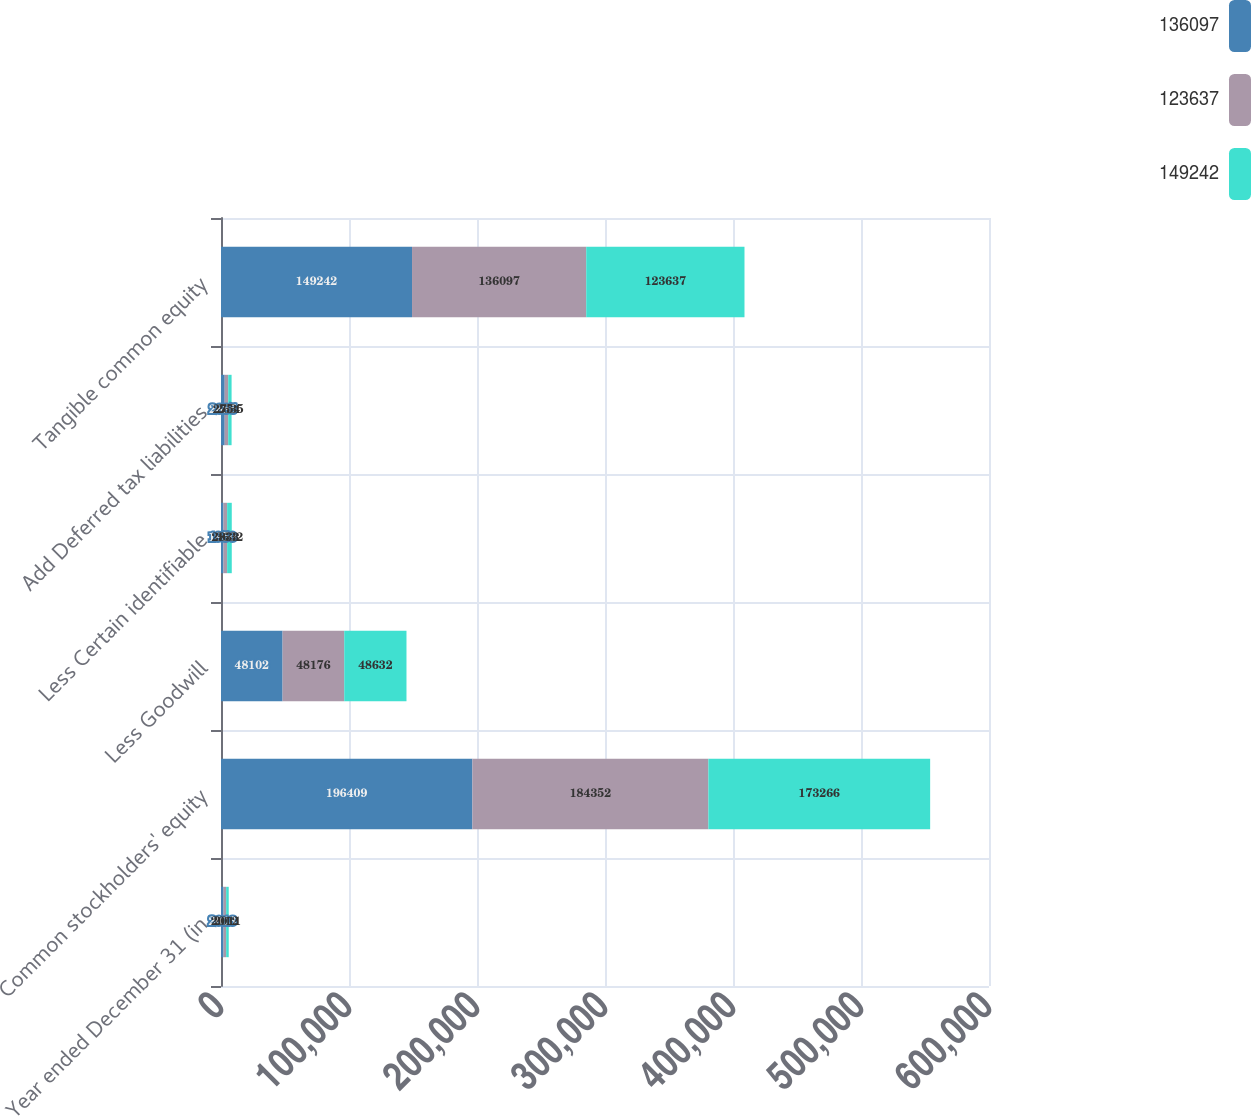<chart> <loc_0><loc_0><loc_500><loc_500><stacked_bar_chart><ecel><fcel>Year ended December 31 (in<fcel>Common stockholders' equity<fcel>Less Goodwill<fcel>Less Certain identifiable<fcel>Add Deferred tax liabilities<fcel>Tangible common equity<nl><fcel>136097<fcel>2013<fcel>196409<fcel>48102<fcel>1950<fcel>2885<fcel>149242<nl><fcel>123637<fcel>2012<fcel>184352<fcel>48176<fcel>2833<fcel>2754<fcel>136097<nl><fcel>149242<fcel>2011<fcel>173266<fcel>48632<fcel>3632<fcel>2635<fcel>123637<nl></chart> 